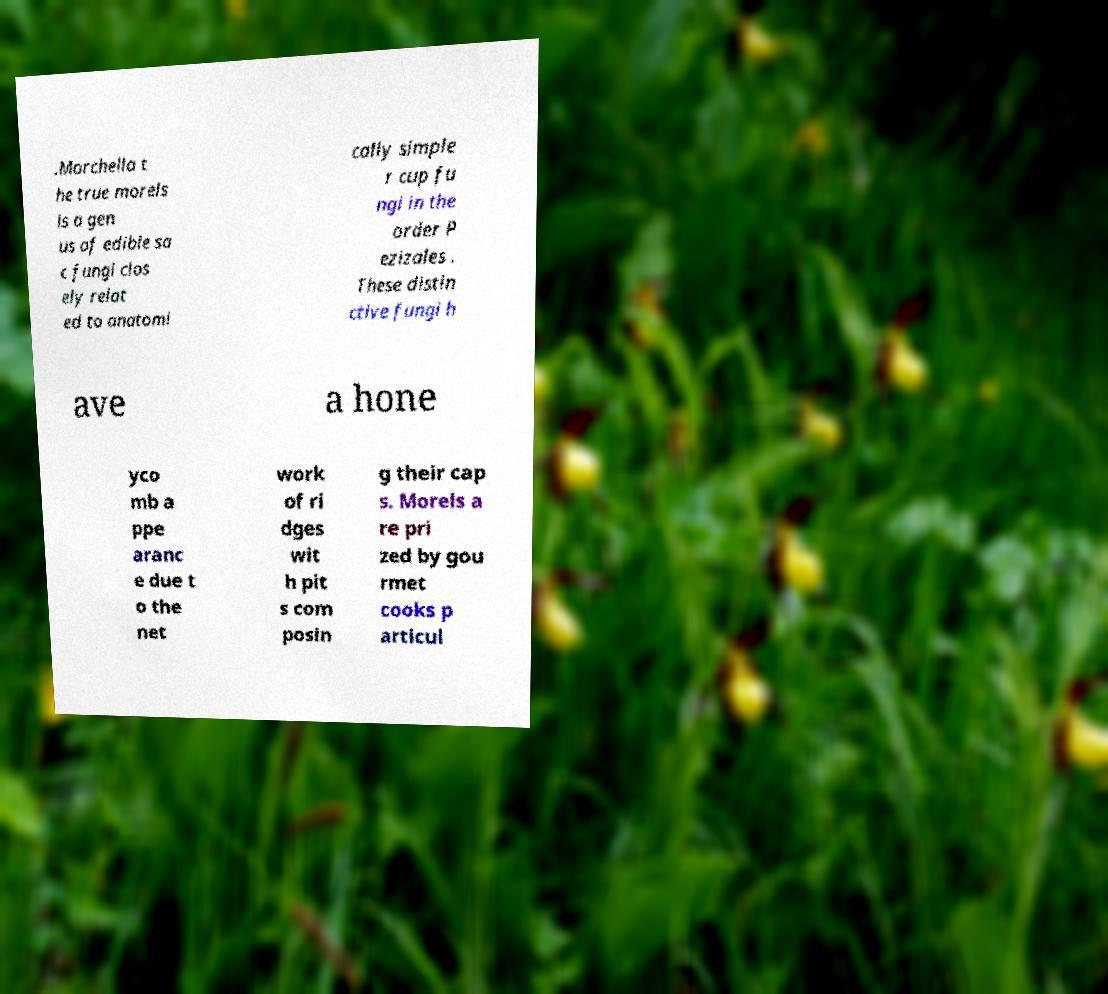Could you extract and type out the text from this image? .Morchella t he true morels is a gen us of edible sa c fungi clos ely relat ed to anatomi cally simple r cup fu ngi in the order P ezizales . These distin ctive fungi h ave a hone yco mb a ppe aranc e due t o the net work of ri dges wit h pit s com posin g their cap s. Morels a re pri zed by gou rmet cooks p articul 